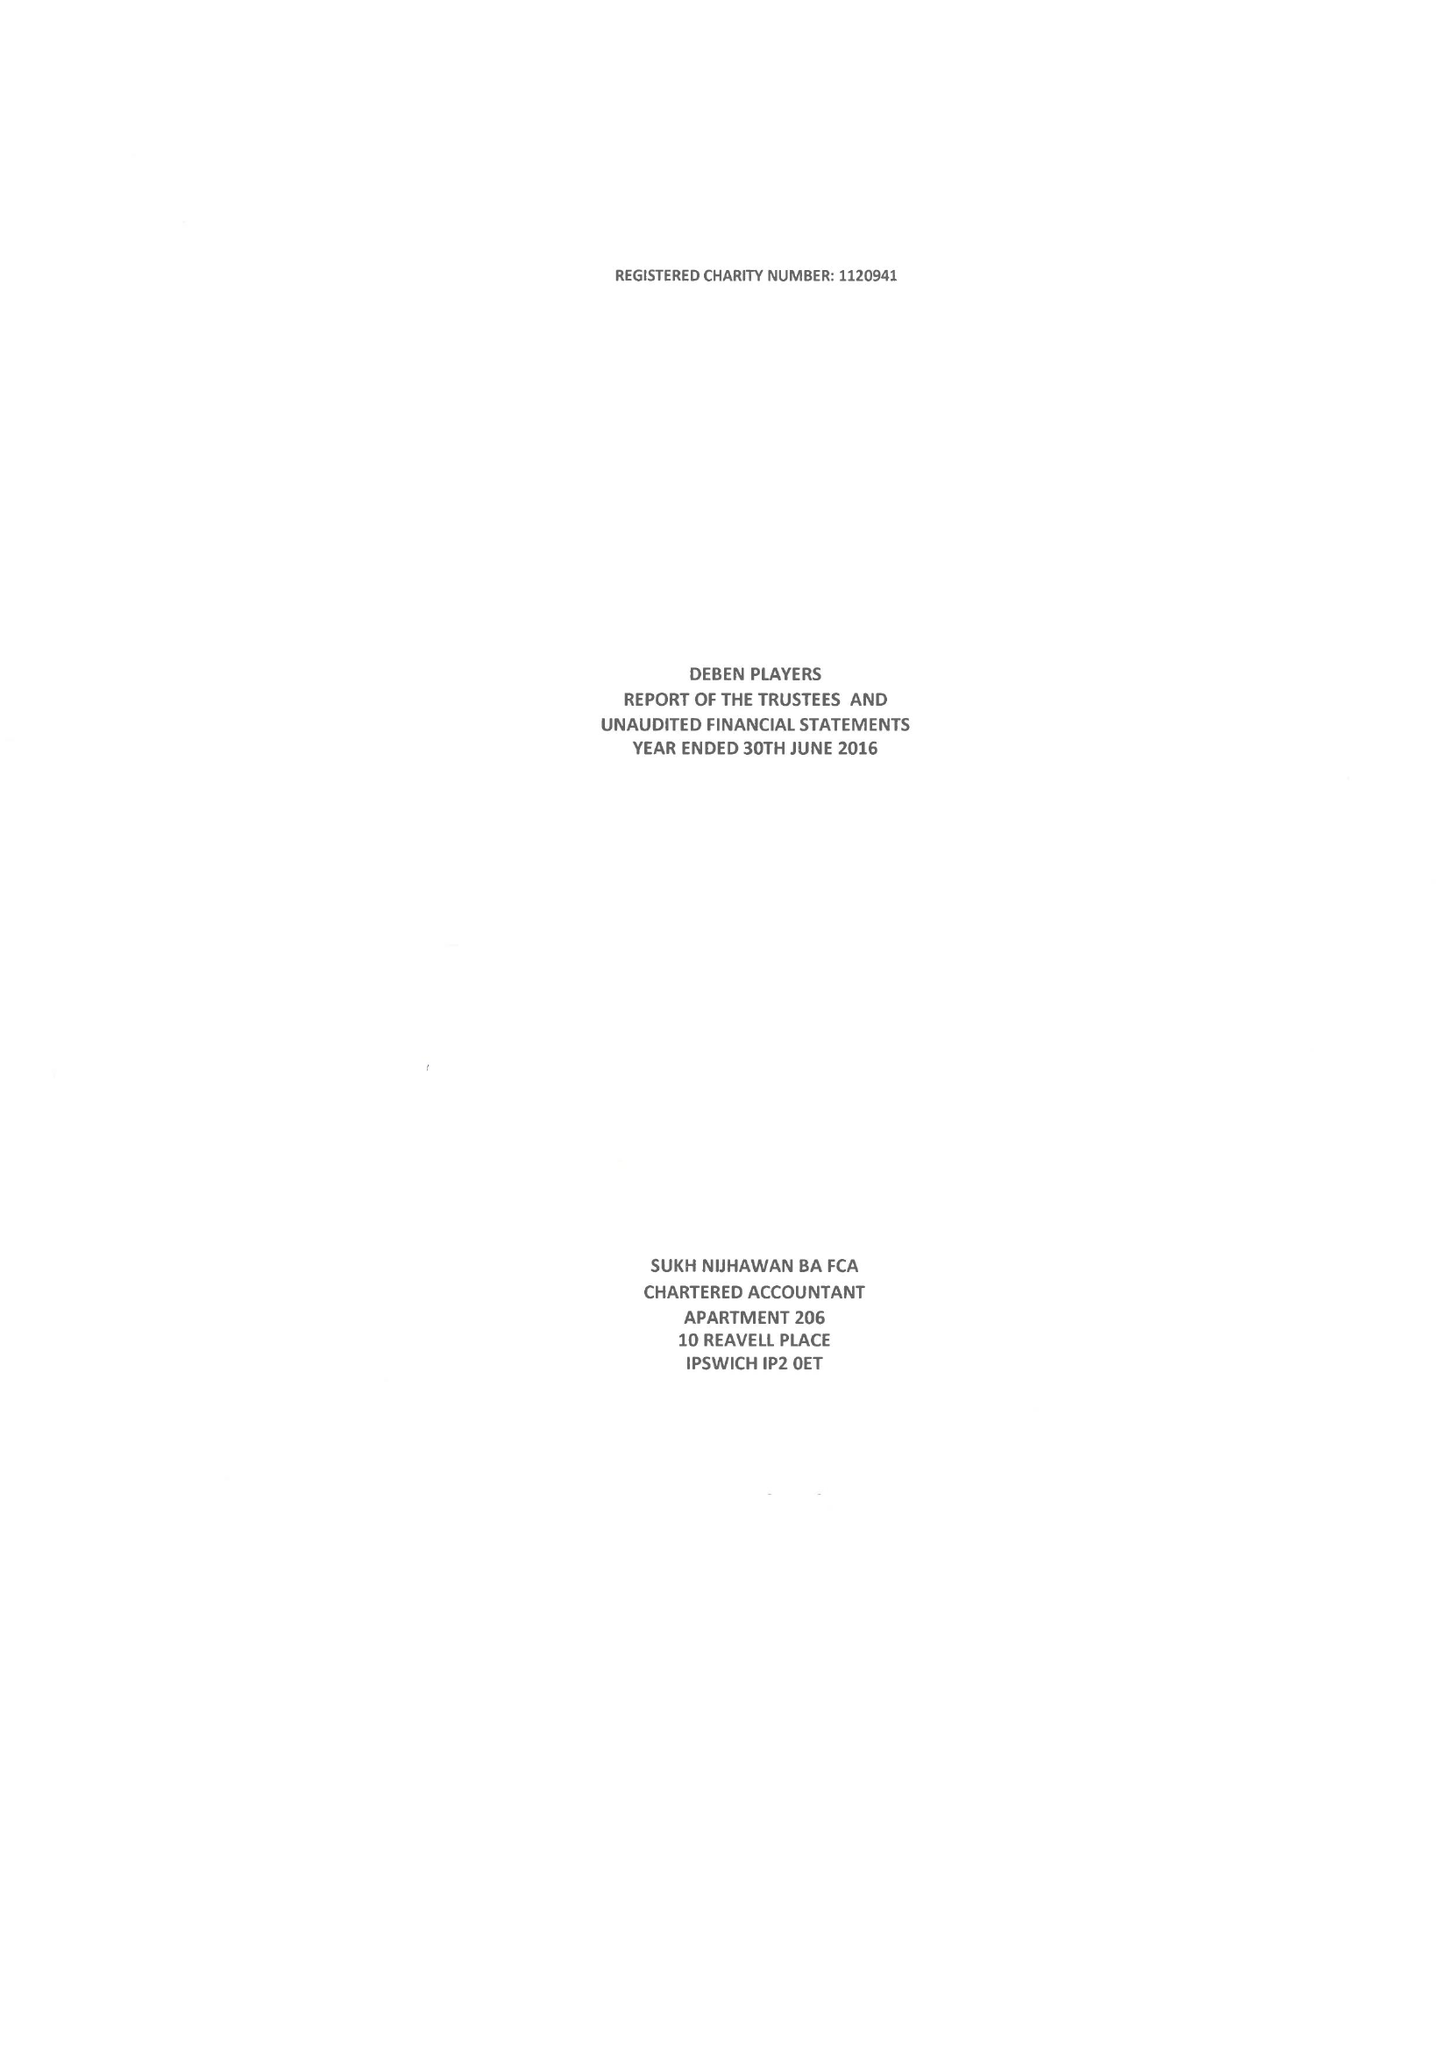What is the value for the charity_name?
Answer the question using a single word or phrase. Deben Players 